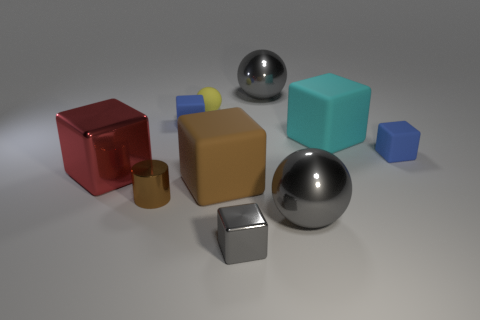Subtract all gray spheres. How many were subtracted if there are1gray spheres left? 1 Subtract all large gray spheres. How many spheres are left? 1 Subtract all red cubes. How many cubes are left? 5 Subtract all red metallic balls. Subtract all tiny gray things. How many objects are left? 9 Add 3 gray blocks. How many gray blocks are left? 4 Add 7 brown rubber cubes. How many brown rubber cubes exist? 8 Subtract 1 gray cubes. How many objects are left? 9 Subtract all cubes. How many objects are left? 4 Subtract 1 cylinders. How many cylinders are left? 0 Subtract all blue cylinders. Subtract all purple blocks. How many cylinders are left? 1 